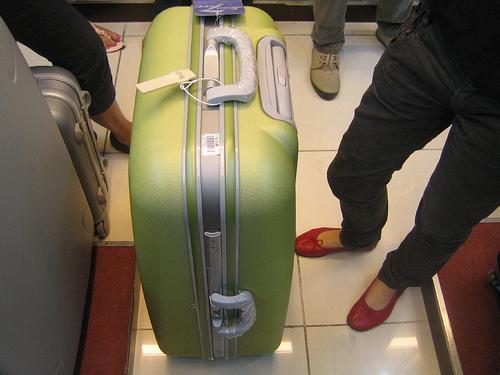How many suitcases are there?
Give a very brief answer. 3. How many people are there?
Give a very brief answer. 3. How many cups in the image are black?
Give a very brief answer. 0. 